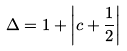<formula> <loc_0><loc_0><loc_500><loc_500>\Delta = 1 + \left | c + \frac { 1 } { 2 } \right |</formula> 